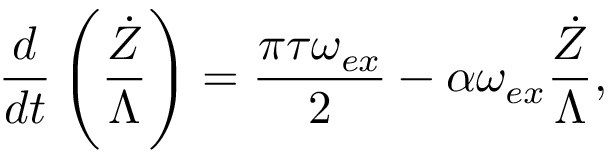Convert formula to latex. <formula><loc_0><loc_0><loc_500><loc_500>\frac { d } { d t } \left ( \frac { \dot { Z } } { \Lambda } \right ) = \frac { \pi \tau \omega _ { e x } } { 2 } - \alpha \omega _ { e x } \frac { \dot { Z } } { \Lambda } ,</formula> 